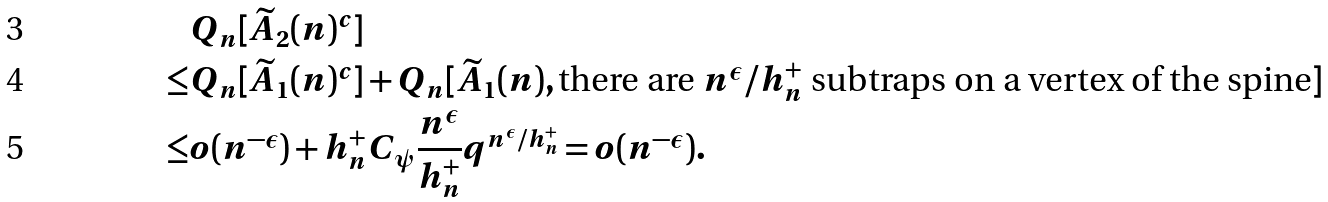<formula> <loc_0><loc_0><loc_500><loc_500>& { Q } _ { n } [ \widetilde { A } _ { 2 } ( n ) ^ { c } ] \\ \leq & { Q } _ { n } [ \widetilde { A } _ { 1 } ( n ) ^ { c } ] + { Q } _ { n } [ \widetilde { A } _ { 1 } ( n ) , \text {there are $n^{\epsilon}/h_{n}^{+}$ subtraps on a vertex of the spine} ] \\ \leq & o ( n ^ { - \epsilon } ) + h _ { n } ^ { + } C _ { \psi } \frac { n ^ { \epsilon } } { h _ { n } ^ { + } } q ^ { n ^ { \epsilon } / h _ { n } ^ { + } } = o ( n ^ { - \epsilon } ) .</formula> 